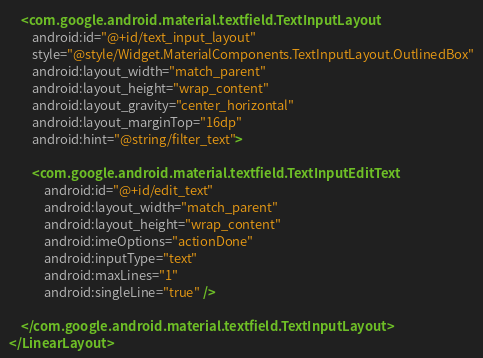Convert code to text. <code><loc_0><loc_0><loc_500><loc_500><_XML_>
    <com.google.android.material.textfield.TextInputLayout
        android:id="@+id/text_input_layout"
        style="@style/Widget.MaterialComponents.TextInputLayout.OutlinedBox"
        android:layout_width="match_parent"
        android:layout_height="wrap_content"
        android:layout_gravity="center_horizontal"
        android:layout_marginTop="16dp"
        android:hint="@string/filter_text">

        <com.google.android.material.textfield.TextInputEditText
            android:id="@+id/edit_text"
            android:layout_width="match_parent"
            android:layout_height="wrap_content"
            android:imeOptions="actionDone"
            android:inputType="text"
            android:maxLines="1"
            android:singleLine="true" />

    </com.google.android.material.textfield.TextInputLayout>
</LinearLayout>
</code> 